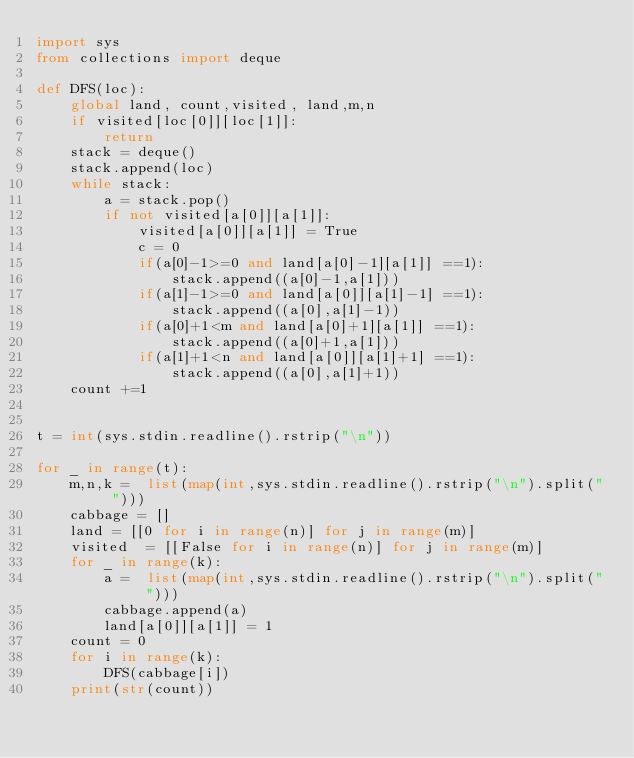<code> <loc_0><loc_0><loc_500><loc_500><_Python_>import sys
from collections import deque

def DFS(loc):
    global land, count,visited, land,m,n
    if visited[loc[0]][loc[1]]:
        return
    stack = deque()
    stack.append(loc)
    while stack:
        a = stack.pop()
        if not visited[a[0]][a[1]]:
            visited[a[0]][a[1]] = True
            c = 0
            if(a[0]-1>=0 and land[a[0]-1][a[1]] ==1):
                stack.append((a[0]-1,a[1]))
            if(a[1]-1>=0 and land[a[0]][a[1]-1] ==1):
                stack.append((a[0],a[1]-1))
            if(a[0]+1<m and land[a[0]+1][a[1]] ==1):
                stack.append((a[0]+1,a[1]))
            if(a[1]+1<n and land[a[0]][a[1]+1] ==1):
                stack.append((a[0],a[1]+1))
    count +=1
            

t = int(sys.stdin.readline().rstrip("\n"))

for _ in range(t):
    m,n,k =  list(map(int,sys.stdin.readline().rstrip("\n").split(" ")))
    cabbage = []
    land = [[0 for i in range(n)] for j in range(m)]
    visited  = [[False for i in range(n)] for j in range(m)]
    for _ in range(k):
        a =  list(map(int,sys.stdin.readline().rstrip("\n").split(" ")))
        cabbage.append(a)
        land[a[0]][a[1]] = 1
    count = 0
    for i in range(k):
        DFS(cabbage[i])
    print(str(count))
        
</code> 